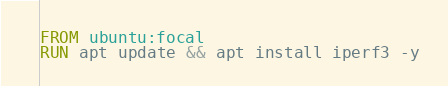<code> <loc_0><loc_0><loc_500><loc_500><_Dockerfile_>FROM ubuntu:focal
RUN apt update && apt install iperf3 -y
</code> 